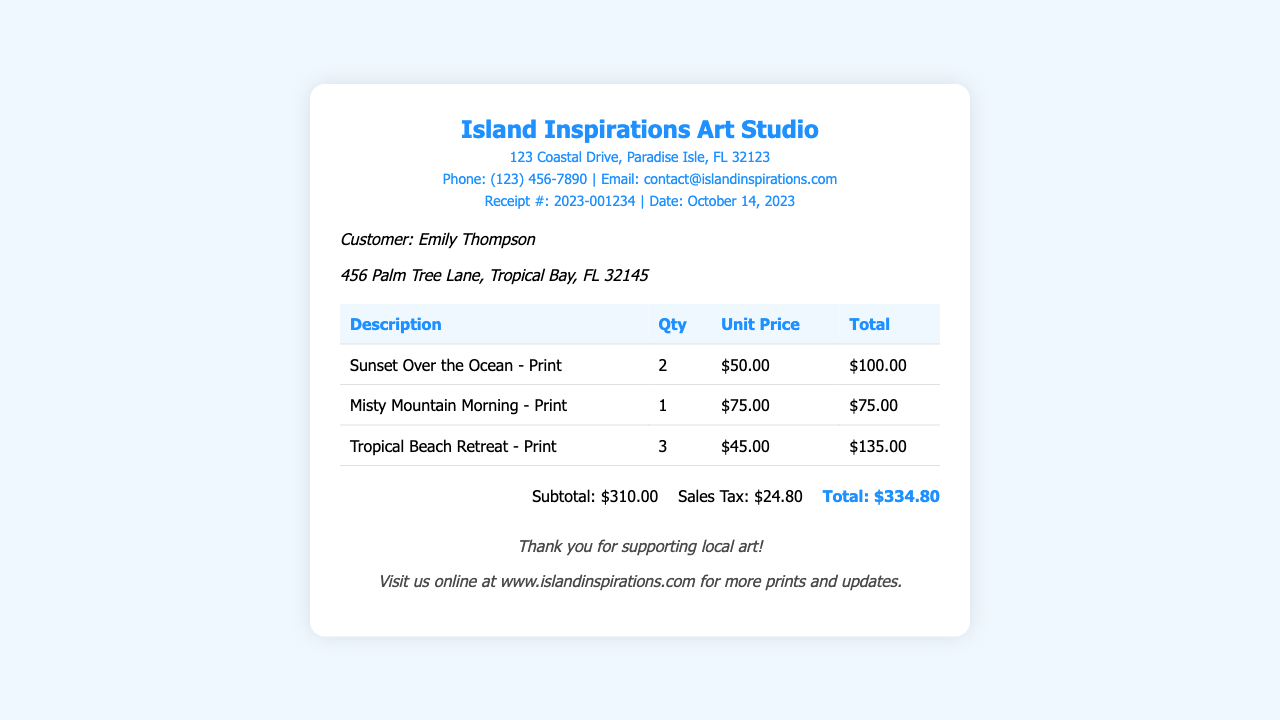What is the receipt number? The receipt number is identified at the top of the document, which is 2023-001234.
Answer: 2023-001234 Who is the customer? The customer's name is mentioned in the customer info section, which is Emily Thompson.
Answer: Emily Thompson What is the total amount due? The total amount is calculated at the bottom, which states that the total is $334.80.
Answer: $334.80 How many prints of "Tropical Beach Retreat" were sold? The quantity sold for "Tropical Beach Retreat" is listed in the table, which is 3.
Answer: 3 What is the sales tax amount? The sales tax is provided in the summary section, which is $24.80.
Answer: $24.80 What was the unit price of "Misty Mountain Morning"? The unit price for "Misty Mountain Morning" is found in the table, which is $75.00.
Answer: $75.00 How much did the customer spend on "Sunset Over the Ocean"? The total cost for "Sunset Over the Ocean" is found in the table through multiplication, which is $100.00.
Answer: $100.00 What is the address of the art studio? The address of the art studio is located in the header section, which is 123 Coastal Drive, Paradise Isle, FL 32123.
Answer: 123 Coastal Drive, Paradise Isle, FL 32123 What type of document is this? The document is a sales receipt, as indicated in the title and format.
Answer: Sales receipt 